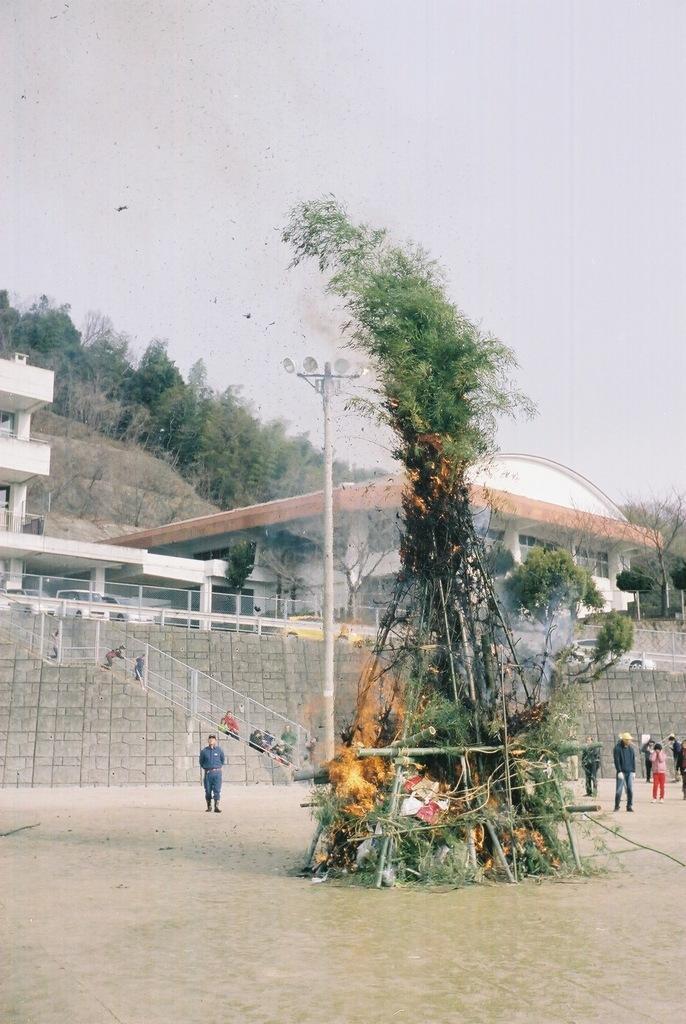Describe this image in one or two sentences. In this image, we can see people wearing clothes. There is a pole in front of the wall. There is a building in the middle of the image. There are some trees on the hill. There is a fire at the bottom of the image. At the top of the image, we can see the sky. 